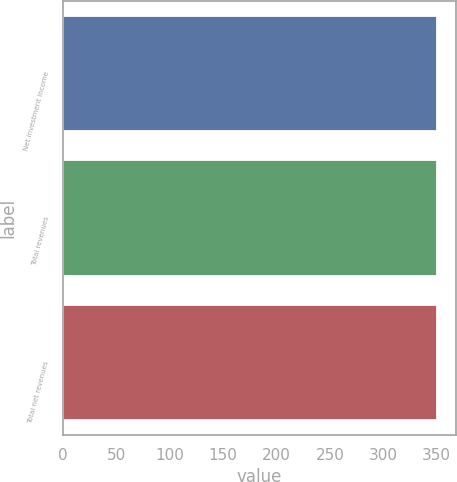Convert chart to OTSL. <chart><loc_0><loc_0><loc_500><loc_500><bar_chart><fcel>Net investment income<fcel>Total revenues<fcel>Total net revenues<nl><fcel>350<fcel>350.1<fcel>350.2<nl></chart> 